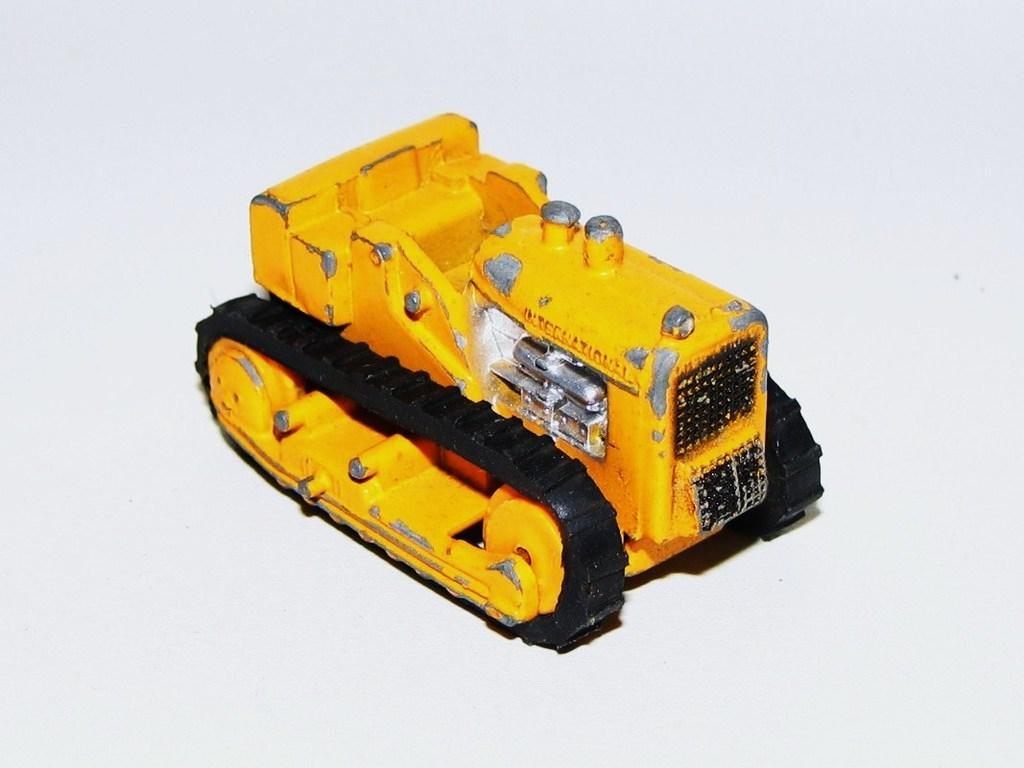What object is the main focus of the image? There is a toy vehicle in the image. What color is the background of the image? The background of the image is white. Can you see a dog playing with scissors in the image? No, there is no dog or scissors present in the image. 